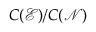Convert formula to latex. <formula><loc_0><loc_0><loc_500><loc_500>C ( \mathcal { E } ) / C ( \mathcal { N } )</formula> 